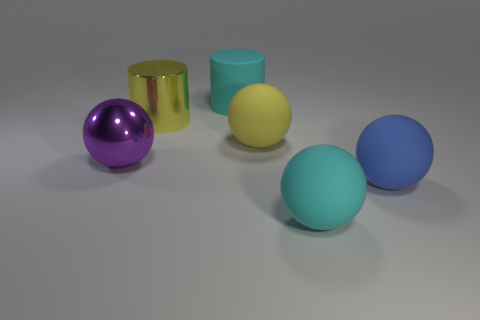What number of other objects are the same shape as the purple object?
Your answer should be very brief. 3. How many large balls are behind the large purple shiny sphere?
Give a very brief answer. 1. Are there any tiny cyan spheres?
Provide a succinct answer. No. How many other things are the same size as the yellow rubber sphere?
Offer a terse response. 5. There is a sphere behind the purple shiny object; is its color the same as the big metallic cylinder that is on the left side of the large blue object?
Your response must be concise. Yes. What is the size of the cyan rubber object that is the same shape as the blue matte object?
Your answer should be very brief. Large. Is the ball that is behind the big purple metal sphere made of the same material as the cyan object behind the cyan ball?
Provide a succinct answer. Yes. How many shiny things are cyan spheres or yellow cylinders?
Offer a very short reply. 1. What material is the yellow thing that is right of the yellow thing that is on the left side of the rubber sphere that is behind the purple sphere?
Provide a short and direct response. Rubber. There is a metallic thing that is behind the yellow rubber thing; does it have the same shape as the big cyan matte thing that is behind the big purple shiny object?
Keep it short and to the point. Yes. 